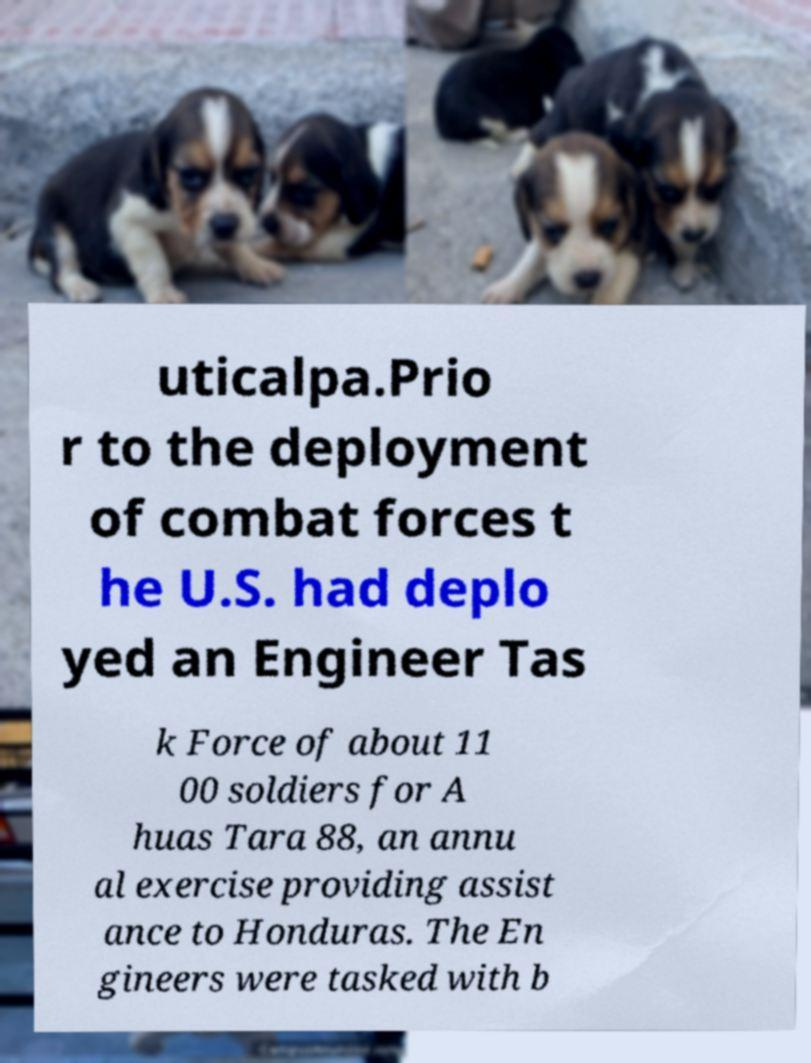There's text embedded in this image that I need extracted. Can you transcribe it verbatim? uticalpa.Prio r to the deployment of combat forces t he U.S. had deplo yed an Engineer Tas k Force of about 11 00 soldiers for A huas Tara 88, an annu al exercise providing assist ance to Honduras. The En gineers were tasked with b 